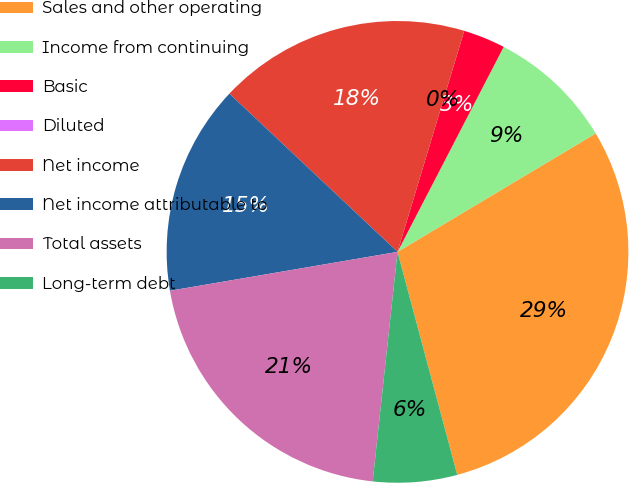Convert chart. <chart><loc_0><loc_0><loc_500><loc_500><pie_chart><fcel>Sales and other operating<fcel>Income from continuing<fcel>Basic<fcel>Diluted<fcel>Net income<fcel>Net income attributable to<fcel>Total assets<fcel>Long-term debt<nl><fcel>29.41%<fcel>8.82%<fcel>2.94%<fcel>0.0%<fcel>17.65%<fcel>14.71%<fcel>20.59%<fcel>5.88%<nl></chart> 